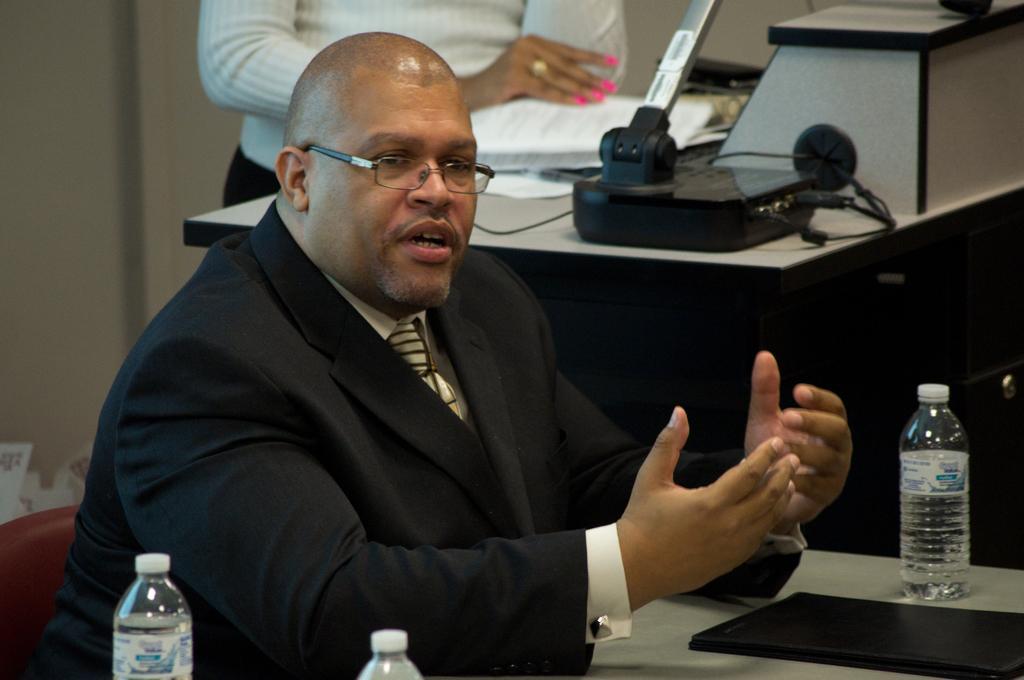How would you summarize this image in a sentence or two? In this picture we can see man sitting on chair and talking and in front of them there is table and on table we can see file, bottle and beside to him we can see headsets, some device, person standing. 